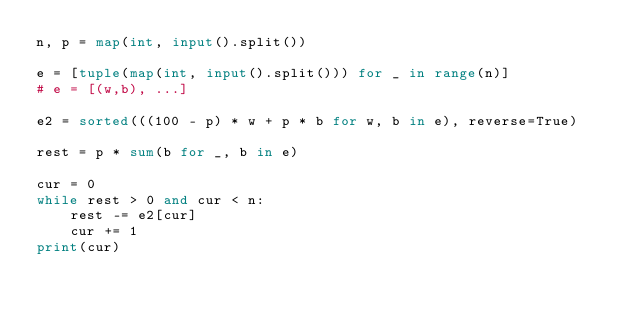Convert code to text. <code><loc_0><loc_0><loc_500><loc_500><_Python_>n, p = map(int, input().split())

e = [tuple(map(int, input().split())) for _ in range(n)]
# e = [(w,b), ...]

e2 = sorted(((100 - p) * w + p * b for w, b in e), reverse=True)

rest = p * sum(b for _, b in e)

cur = 0
while rest > 0 and cur < n:
    rest -= e2[cur]
    cur += 1
print(cur)
</code> 